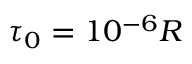<formula> <loc_0><loc_0><loc_500><loc_500>\tau _ { 0 } = 1 0 ^ { - 6 } R</formula> 